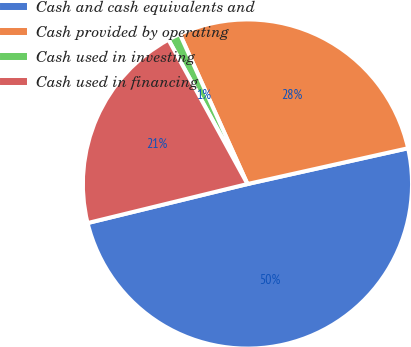<chart> <loc_0><loc_0><loc_500><loc_500><pie_chart><fcel>Cash and cash equivalents and<fcel>Cash provided by operating<fcel>Cash used in investing<fcel>Cash used in financing<nl><fcel>49.68%<fcel>28.25%<fcel>1.23%<fcel>20.84%<nl></chart> 